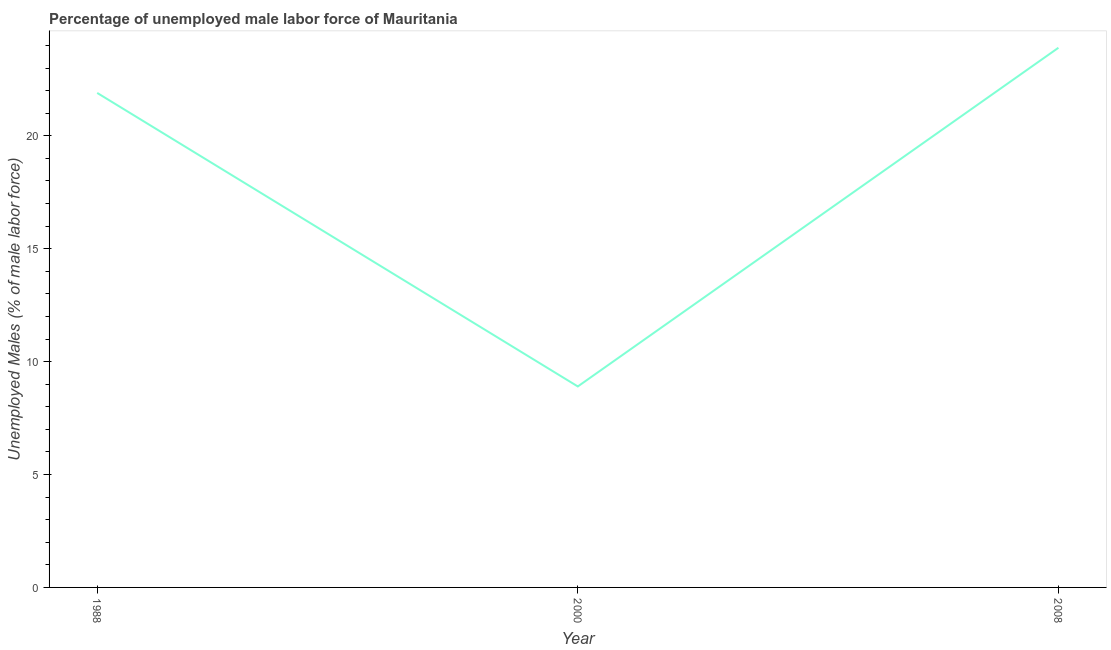What is the total unemployed male labour force in 1988?
Your answer should be compact. 21.9. Across all years, what is the maximum total unemployed male labour force?
Provide a succinct answer. 23.9. Across all years, what is the minimum total unemployed male labour force?
Your answer should be very brief. 8.9. What is the sum of the total unemployed male labour force?
Ensure brevity in your answer.  54.7. What is the average total unemployed male labour force per year?
Offer a terse response. 18.23. What is the median total unemployed male labour force?
Your answer should be very brief. 21.9. Do a majority of the years between 2000 and 2008 (inclusive) have total unemployed male labour force greater than 17 %?
Offer a terse response. No. What is the ratio of the total unemployed male labour force in 2000 to that in 2008?
Your answer should be very brief. 0.37. Is the total unemployed male labour force in 1988 less than that in 2008?
Provide a succinct answer. Yes. Is the sum of the total unemployed male labour force in 1988 and 2000 greater than the maximum total unemployed male labour force across all years?
Make the answer very short. Yes. What is the difference between the highest and the lowest total unemployed male labour force?
Give a very brief answer. 15. How many lines are there?
Offer a terse response. 1. What is the title of the graph?
Offer a terse response. Percentage of unemployed male labor force of Mauritania. What is the label or title of the Y-axis?
Provide a succinct answer. Unemployed Males (% of male labor force). What is the Unemployed Males (% of male labor force) in 1988?
Ensure brevity in your answer.  21.9. What is the Unemployed Males (% of male labor force) in 2000?
Provide a short and direct response. 8.9. What is the Unemployed Males (% of male labor force) of 2008?
Ensure brevity in your answer.  23.9. What is the difference between the Unemployed Males (% of male labor force) in 1988 and 2000?
Provide a short and direct response. 13. What is the difference between the Unemployed Males (% of male labor force) in 1988 and 2008?
Make the answer very short. -2. What is the difference between the Unemployed Males (% of male labor force) in 2000 and 2008?
Provide a short and direct response. -15. What is the ratio of the Unemployed Males (% of male labor force) in 1988 to that in 2000?
Make the answer very short. 2.46. What is the ratio of the Unemployed Males (% of male labor force) in 1988 to that in 2008?
Provide a succinct answer. 0.92. What is the ratio of the Unemployed Males (% of male labor force) in 2000 to that in 2008?
Ensure brevity in your answer.  0.37. 